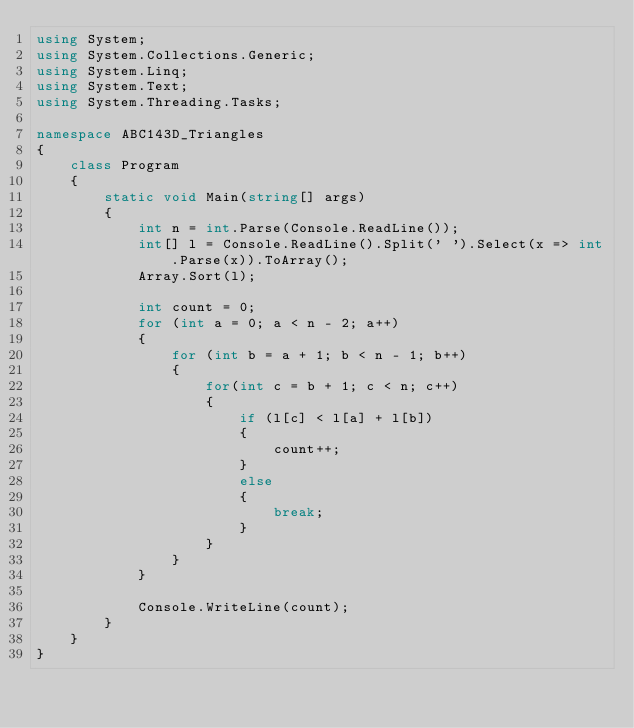<code> <loc_0><loc_0><loc_500><loc_500><_C#_>using System;
using System.Collections.Generic;
using System.Linq;
using System.Text;
using System.Threading.Tasks;

namespace ABC143D_Triangles
{
    class Program
    {
        static void Main(string[] args)
        {
            int n = int.Parse(Console.ReadLine());
            int[] l = Console.ReadLine().Split(' ').Select(x => int.Parse(x)).ToArray();
            Array.Sort(l);

            int count = 0;
            for (int a = 0; a < n - 2; a++)
            {
                for (int b = a + 1; b < n - 1; b++)
                {
                    for(int c = b + 1; c < n; c++)
                    {
                        if (l[c] < l[a] + l[b])
                        {
                            count++;
                        }
                        else
                        {
                            break;
                        }
                    }
                }
            }

            Console.WriteLine(count);
        }
    }
}
</code> 